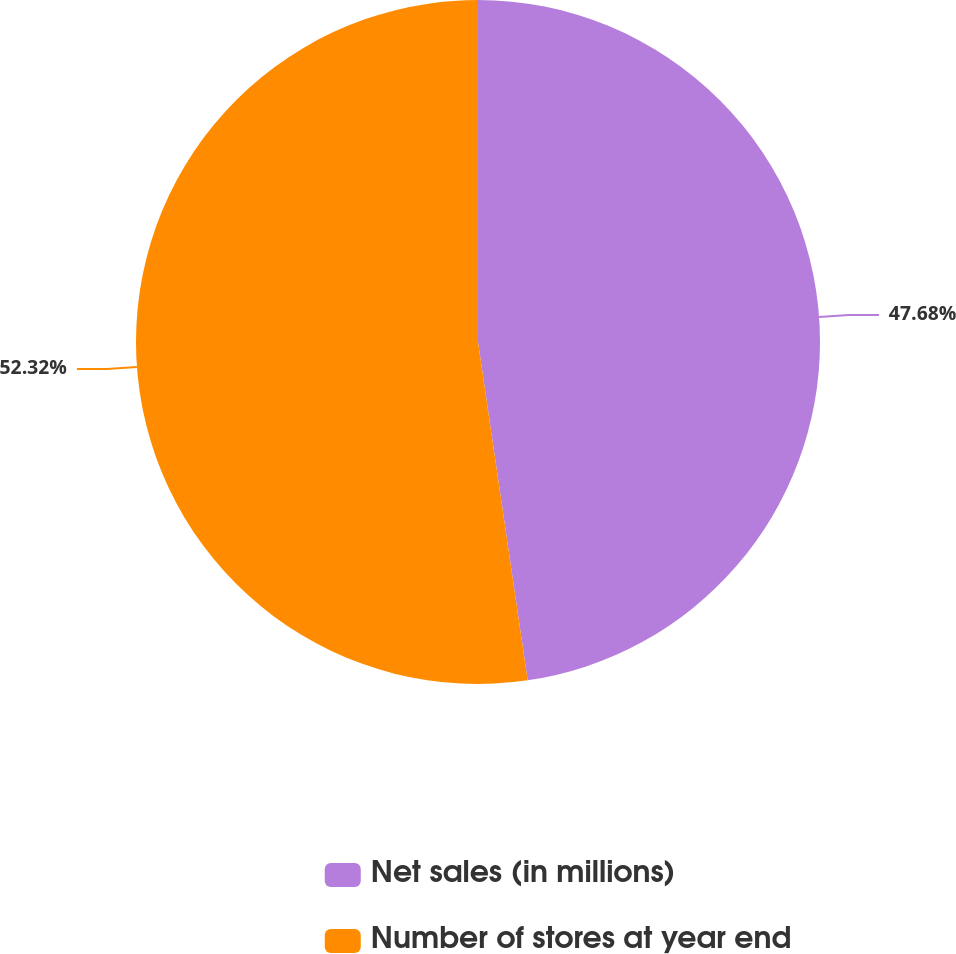Convert chart to OTSL. <chart><loc_0><loc_0><loc_500><loc_500><pie_chart><fcel>Net sales (in millions)<fcel>Number of stores at year end<nl><fcel>47.68%<fcel>52.32%<nl></chart> 